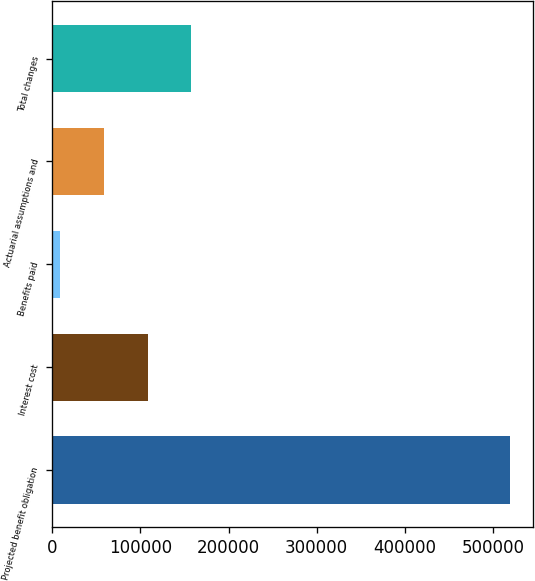Convert chart. <chart><loc_0><loc_0><loc_500><loc_500><bar_chart><fcel>Projected benefit obligation<fcel>Interest cost<fcel>Benefits paid<fcel>Actuarial assumptions and<fcel>Total changes<nl><fcel>519259<fcel>108358<fcel>9233<fcel>58795.6<fcel>157921<nl></chart> 